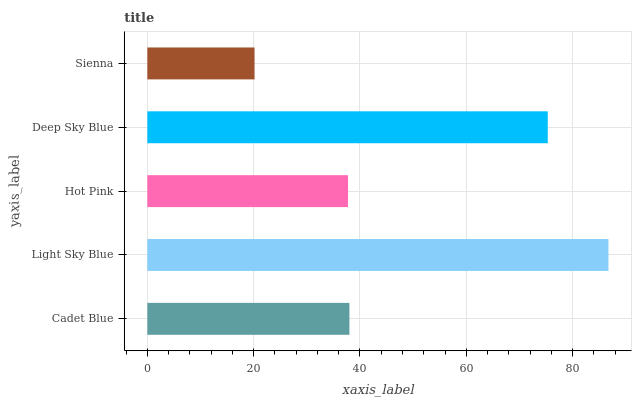Is Sienna the minimum?
Answer yes or no. Yes. Is Light Sky Blue the maximum?
Answer yes or no. Yes. Is Hot Pink the minimum?
Answer yes or no. No. Is Hot Pink the maximum?
Answer yes or no. No. Is Light Sky Blue greater than Hot Pink?
Answer yes or no. Yes. Is Hot Pink less than Light Sky Blue?
Answer yes or no. Yes. Is Hot Pink greater than Light Sky Blue?
Answer yes or no. No. Is Light Sky Blue less than Hot Pink?
Answer yes or no. No. Is Cadet Blue the high median?
Answer yes or no. Yes. Is Cadet Blue the low median?
Answer yes or no. Yes. Is Hot Pink the high median?
Answer yes or no. No. Is Light Sky Blue the low median?
Answer yes or no. No. 